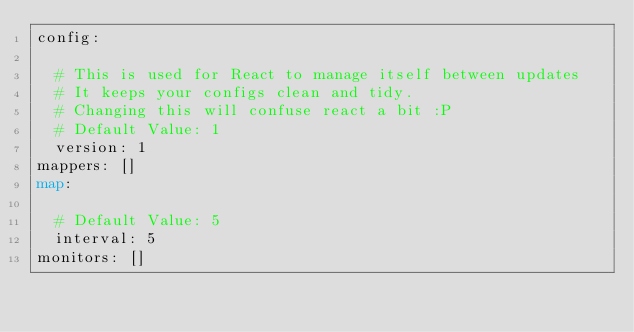<code> <loc_0><loc_0><loc_500><loc_500><_YAML_>config:
 
  # This is used for React to manage itself between updates
  # It keeps your configs clean and tidy.
  # Changing this will confuse react a bit :P
  # Default Value: 1
  version: 1
mappers: []
map:
 
  # Default Value: 5
  interval: 5
monitors: []
</code> 